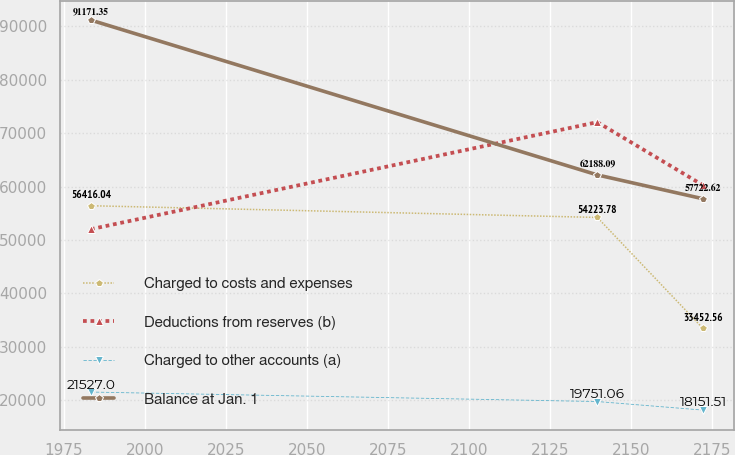Convert chart. <chart><loc_0><loc_0><loc_500><loc_500><line_chart><ecel><fcel>Charged to costs and expenses<fcel>Deductions from reserves (b)<fcel>Charged to other accounts (a)<fcel>Balance at Jan. 1<nl><fcel>1983.29<fcel>56416<fcel>52028.9<fcel>21527<fcel>91171.4<nl><fcel>2139.54<fcel>54223.8<fcel>72069.6<fcel>19751.1<fcel>62188.1<nl><fcel>2172.13<fcel>33452.6<fcel>60259.6<fcel>18151.5<fcel>57722.6<nl></chart> 